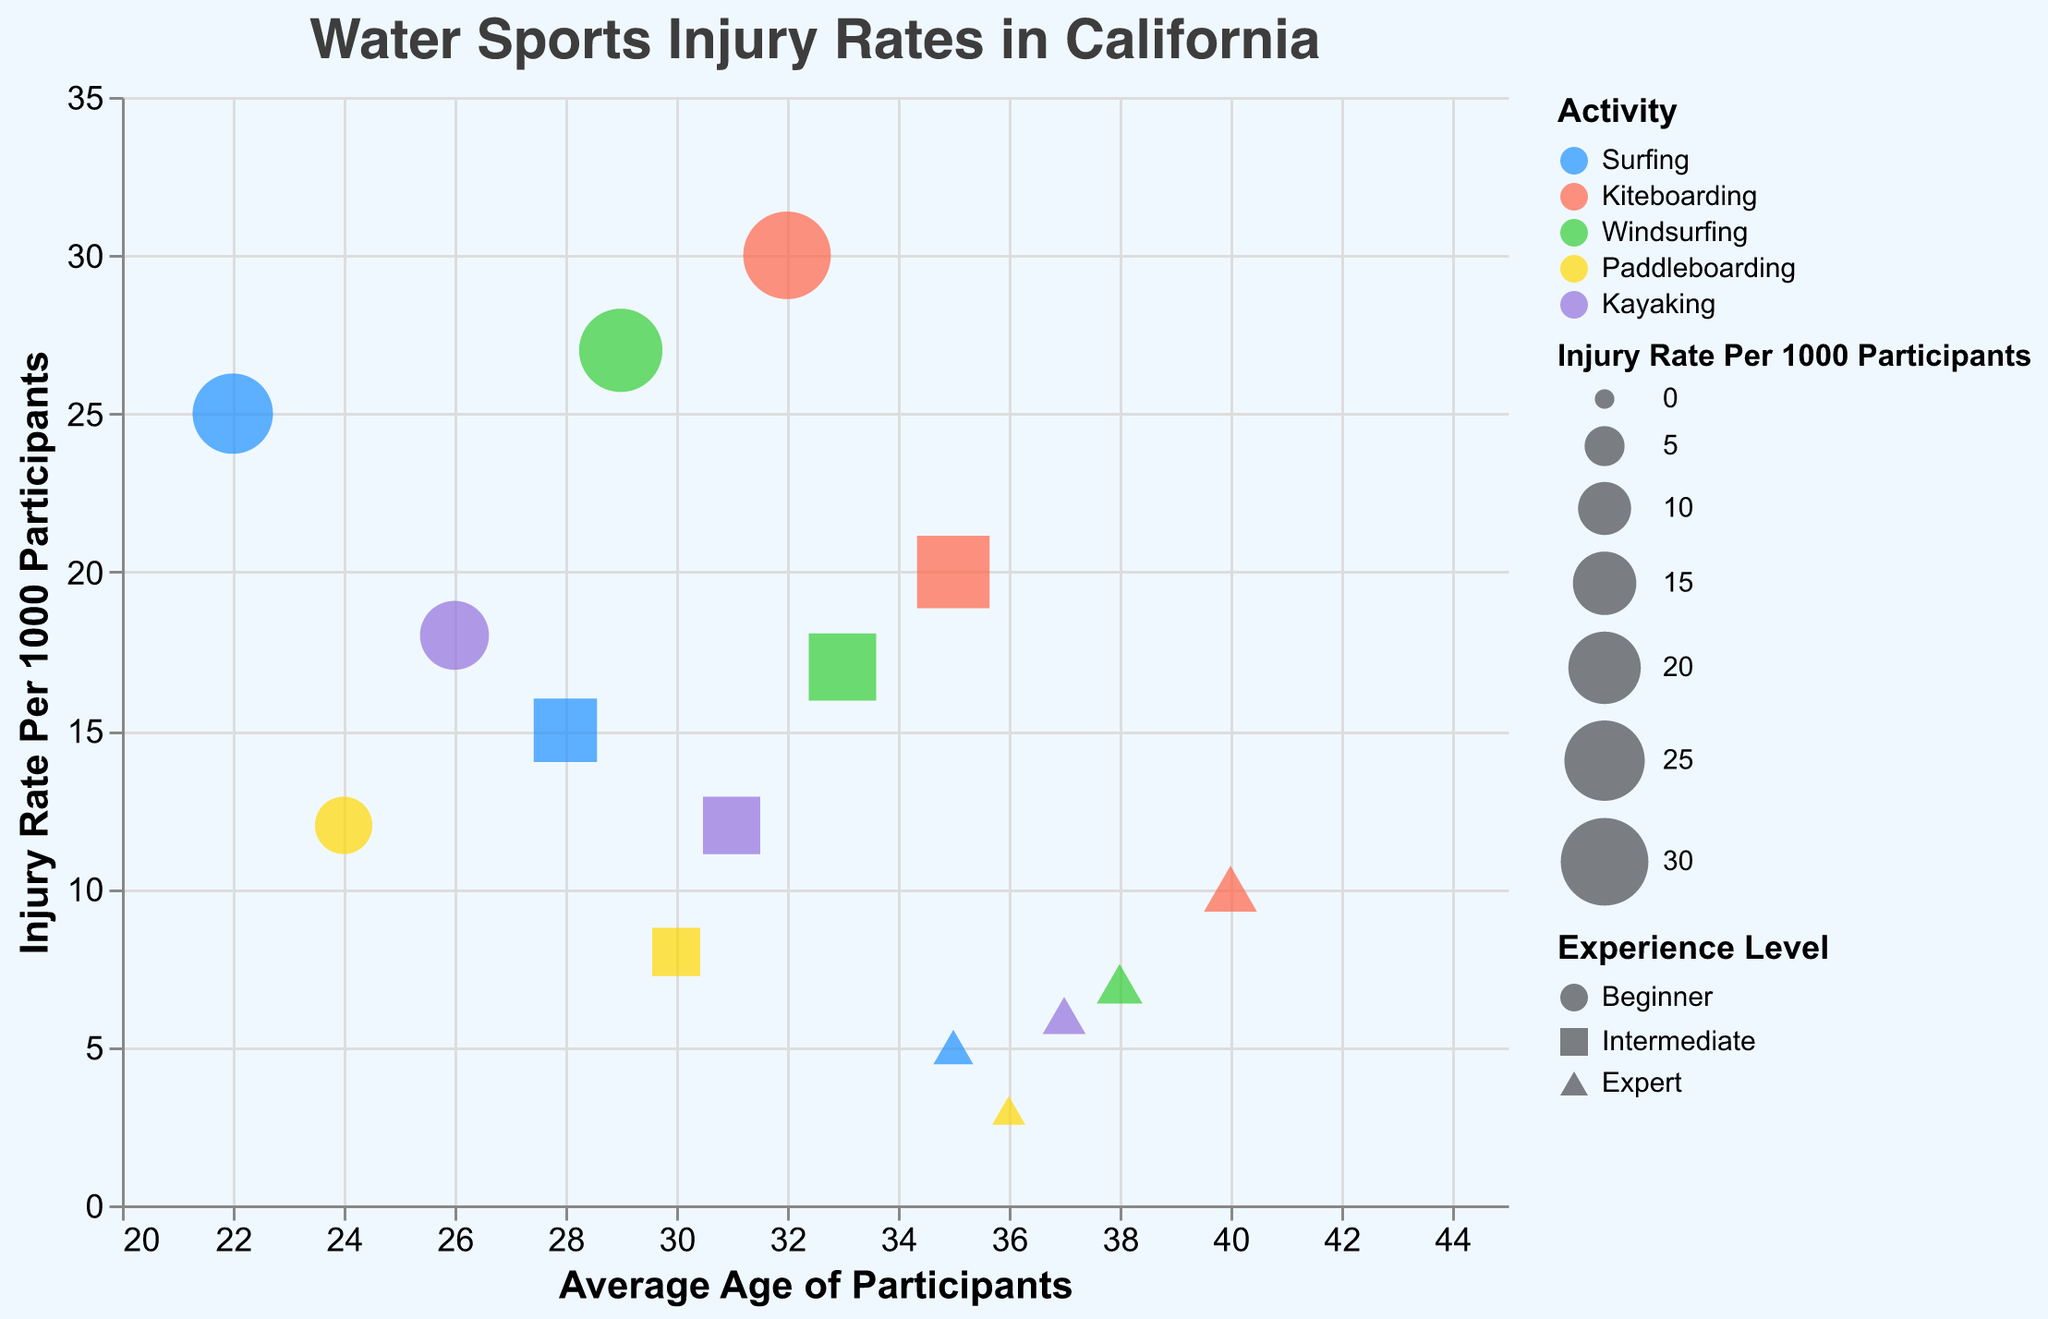What's the injury rate for beginner kiteboarders? Identify the kiteboarding activity, look for the beginner experience level, and note the injury rate for that combination.
Answer: 30 Which activity has the lowest injury rate for experts? Find the injury rate values for expert participants across all activities and identify the lowest value.
Answer: Paddleboarding What is the average age of participants for intermediate windsurfers? Identify the windsurfing activity, look for the intermediate experience level, and note the average age of participants for that combination.
Answer: 33 How does the injury rate for beginner surfers compare to beginner windsurfers? Find and compare the injury rates for beginner-level participants in both surfing and windsurfing activities.
Answer: Beginner windsurfing has a higher injury rate (27 vs. 25) Among intermediate-level participants, which activity has the highest injury rate? Identify the injury rates for intermediate participants across all activities and find the highest value.
Answer: Kiteboarding What's the difference in injury rates between beginner and expert kayakers? Calculate the difference by subtracting injury rate for expert kayakers from the injury rate for beginner kayakers.
Answer: 12 Which activity shows the greatest decrease in injury rates from beginner to expert levels? Calculate the decrease in injury rates from beginner to expert for each activity and identify the largest decrease.
Answer: Kiteboarding How many data points represent intermediate participants? Count the number of data points labeled with the intermediate experience level across all activities.
Answer: 5 What is the highest injury rate observed in this chart, and for which activity and experience level is it? Identify the maximum injury rate value and provide the corresponding activity and experience levels.
Answer: 30, Kiteboarding Beginner Is there a trend between average age and injury rates among the different experience levels within paddleboarding? If so, describe it. Observe paddleboarding data points and compare the injury rates with the average ages for beginner, intermediate, and expert participants.
Answer: As experience level increases, both the average age and injury rates decrease 